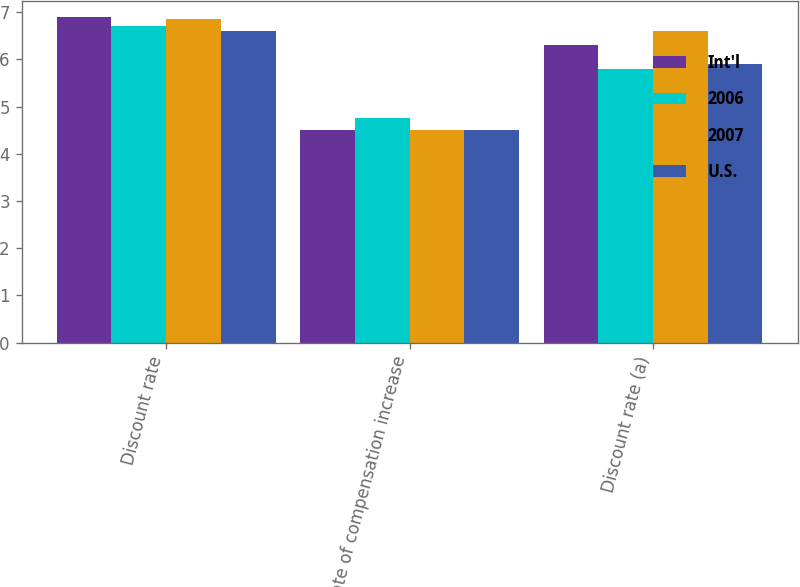Convert chart to OTSL. <chart><loc_0><loc_0><loc_500><loc_500><stacked_bar_chart><ecel><fcel>Discount rate<fcel>Rate of compensation increase<fcel>Discount rate (a)<nl><fcel>Int'l<fcel>6.9<fcel>4.5<fcel>6.3<nl><fcel>2006<fcel>6.7<fcel>4.75<fcel>5.8<nl><fcel>2007<fcel>6.85<fcel>4.5<fcel>6.6<nl><fcel>U.S.<fcel>6.6<fcel>4.5<fcel>5.9<nl></chart> 